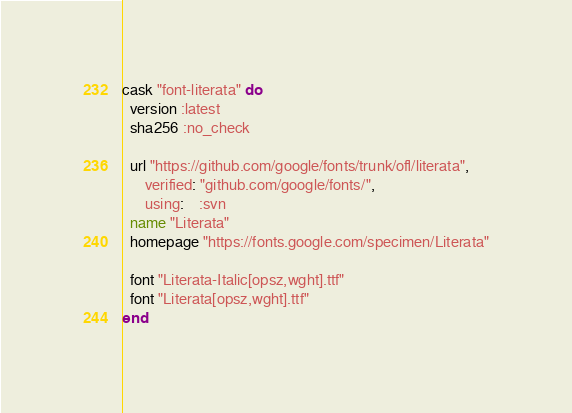<code> <loc_0><loc_0><loc_500><loc_500><_Ruby_>cask "font-literata" do
  version :latest
  sha256 :no_check

  url "https://github.com/google/fonts/trunk/ofl/literata",
      verified: "github.com/google/fonts/",
      using:    :svn
  name "Literata"
  homepage "https://fonts.google.com/specimen/Literata"

  font "Literata-Italic[opsz,wght].ttf"
  font "Literata[opsz,wght].ttf"
end
</code> 